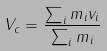Convert formula to latex. <formula><loc_0><loc_0><loc_500><loc_500>V _ { c } = \frac { \sum _ { i } m _ { i } v _ { i } } { \sum _ { i } m _ { i } }</formula> 